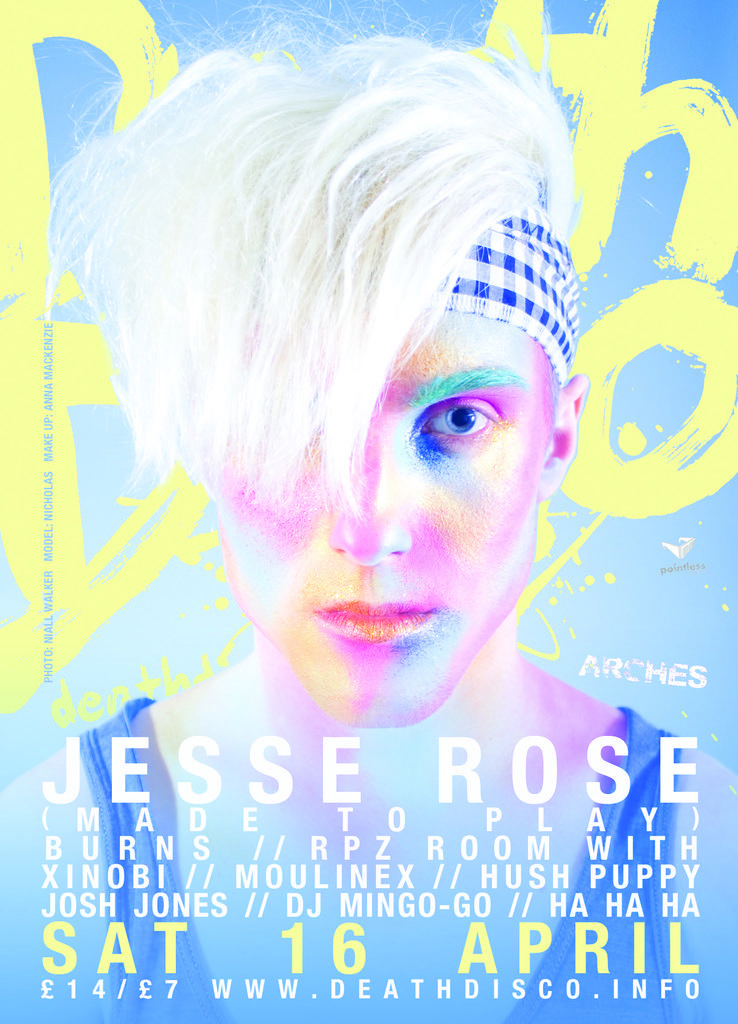Describe this image in one or two sentences. In the image there is a poster. On the poster there is an image of a person and also there is something written on it. 